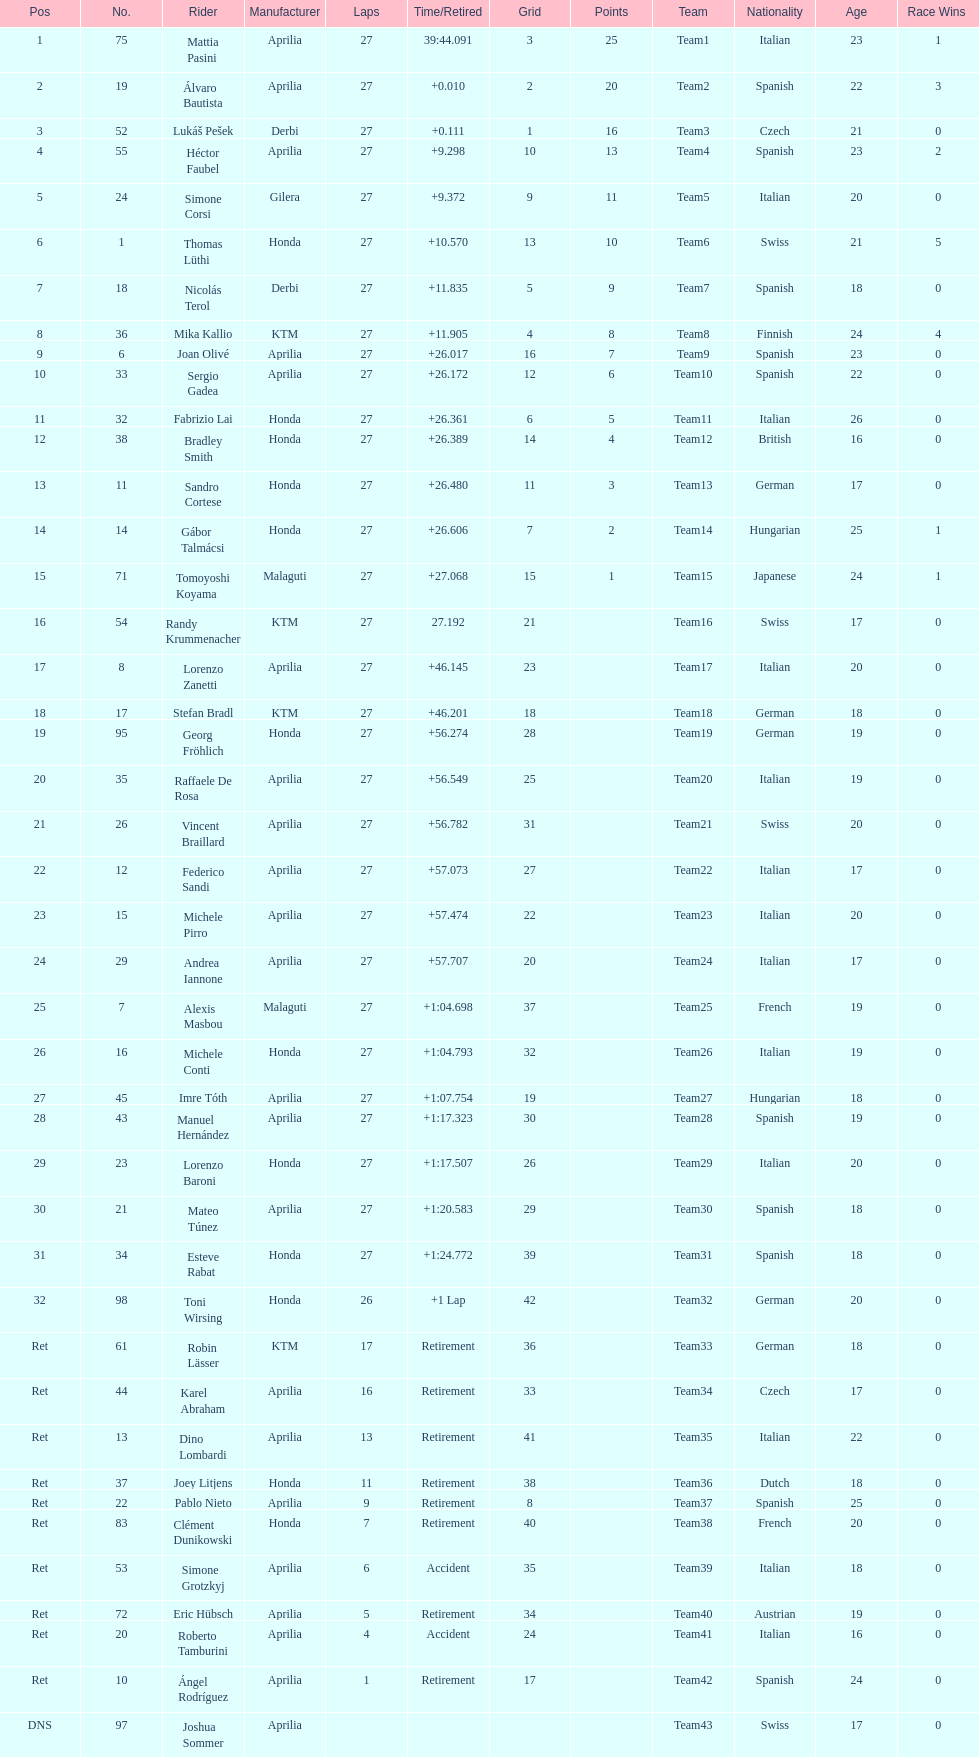Name a racer that had at least 20 points. Mattia Pasini. 